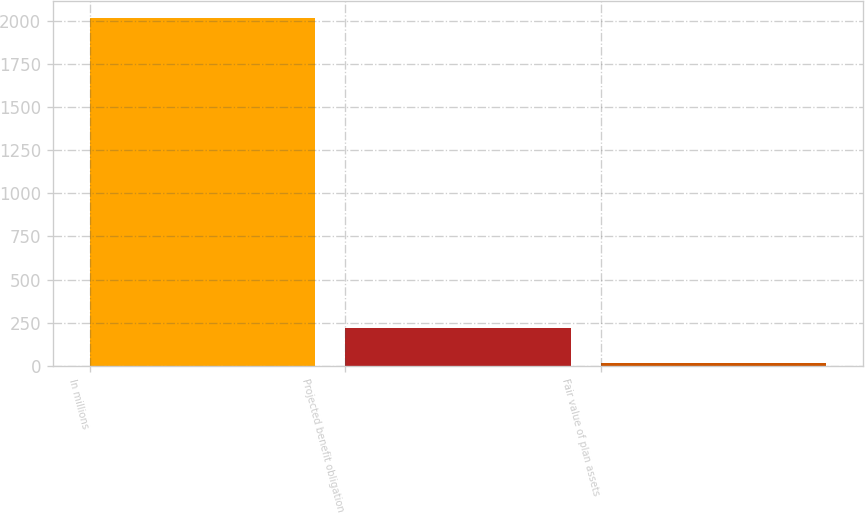Convert chart to OTSL. <chart><loc_0><loc_0><loc_500><loc_500><bar_chart><fcel>In millions<fcel>Projected benefit obligation<fcel>Fair value of plan assets<nl><fcel>2015<fcel>216.44<fcel>16.6<nl></chart> 